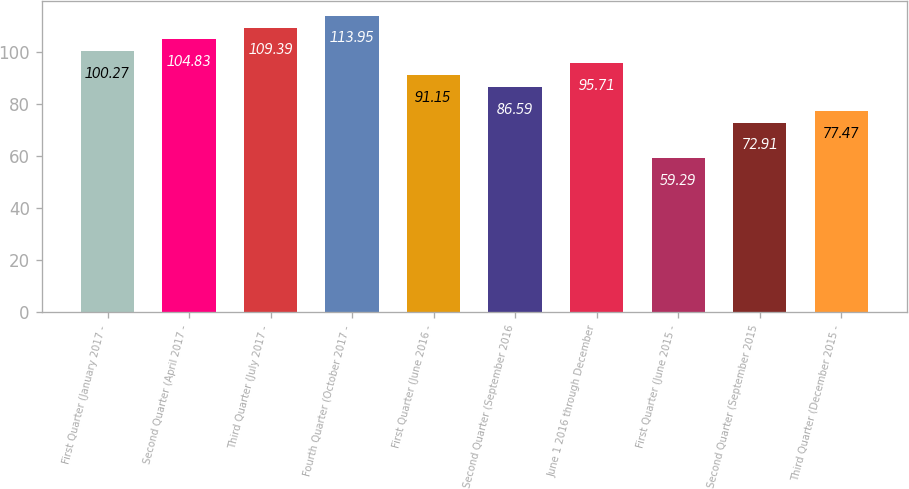<chart> <loc_0><loc_0><loc_500><loc_500><bar_chart><fcel>First Quarter (January 2017 -<fcel>Second Quarter (April 2017 -<fcel>Third Quarter (July 2017 -<fcel>Fourth Quarter (October 2017 -<fcel>First Quarter (June 2016 -<fcel>Second Quarter (September 2016<fcel>June 1 2016 through December<fcel>First Quarter (June 2015 -<fcel>Second Quarter (September 2015<fcel>Third Quarter (December 2015 -<nl><fcel>100.27<fcel>104.83<fcel>109.39<fcel>113.95<fcel>91.15<fcel>86.59<fcel>95.71<fcel>59.29<fcel>72.91<fcel>77.47<nl></chart> 